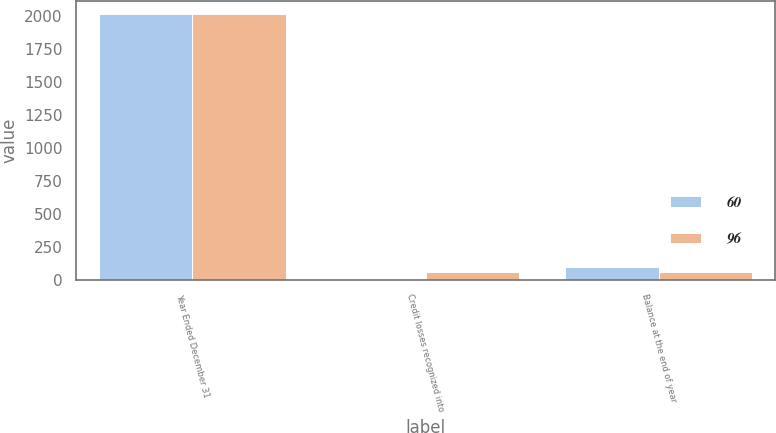<chart> <loc_0><loc_0><loc_500><loc_500><stacked_bar_chart><ecel><fcel>Year Ended December 31<fcel>Credit losses recognized into<fcel>Balance at the end of year<nl><fcel>60<fcel>2010<fcel>7<fcel>96<nl><fcel>96<fcel>2009<fcel>60<fcel>60<nl></chart> 